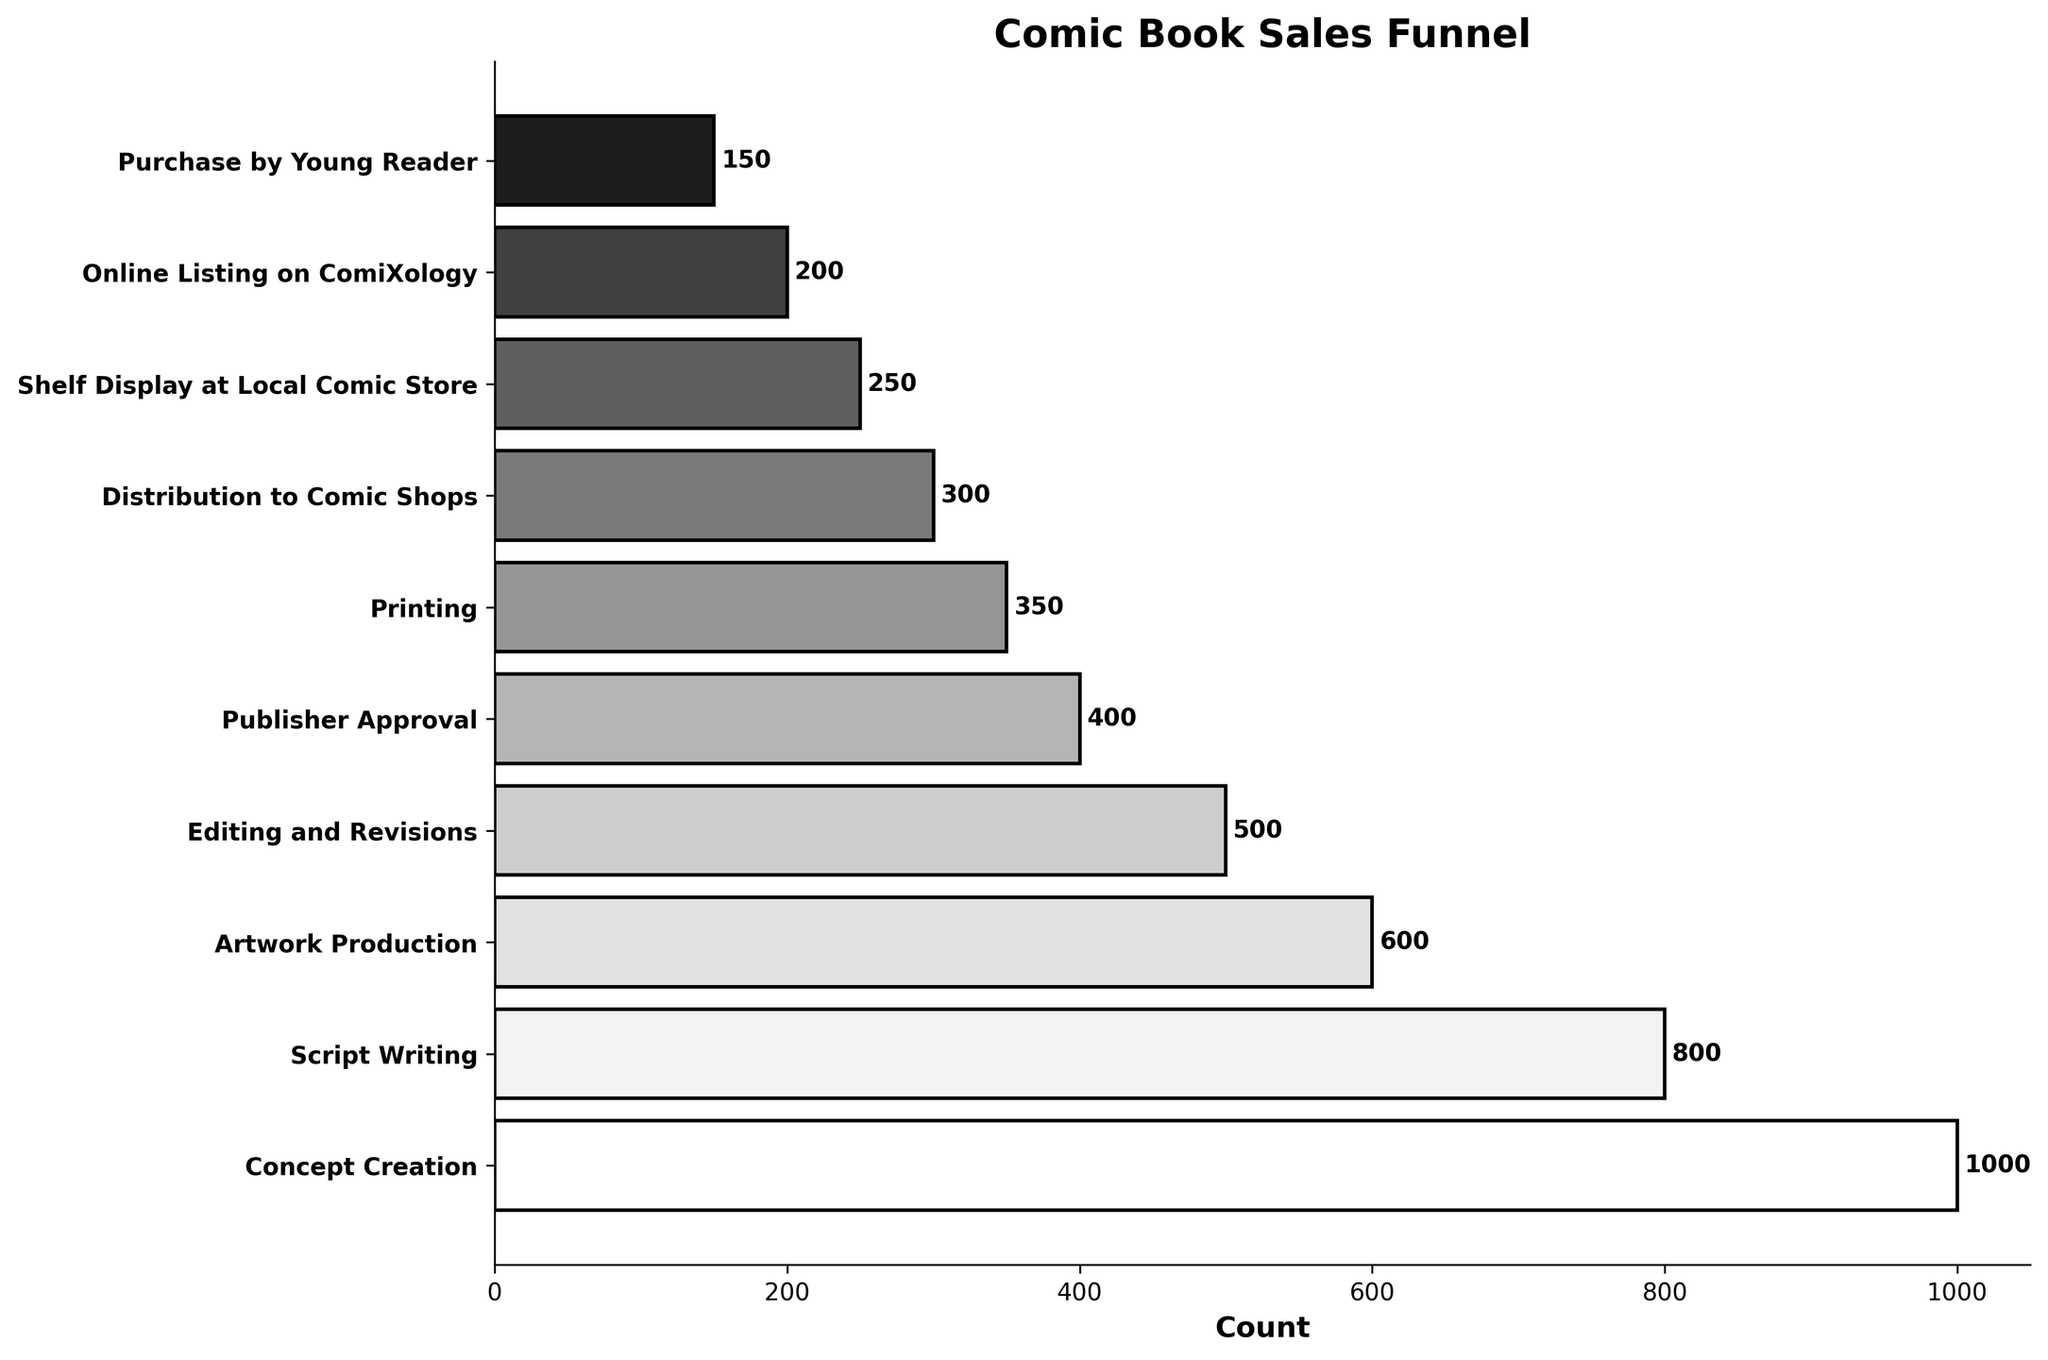What's the title of the figure? The title is displayed prominently at the top of the figure in bold font. It provides the context of the visualization.
Answer: Comic Book Sales Funnel How many stages are there in the comic book sales process? The y-axis of the funnel chart lists all the stages in the process, each represented as a horizontal bar. Counting these bars will give the number of stages.
Answer: 10 What is the count at the "Script Writing" stage? Looking at the bar labeled "Script Writing," the count label next to it is the value we are looking for.
Answer: 800 How many more comics are at the "Concept Creation" stage compared to the "Shelf Display at Local Comic Store" stage? Subtract the count at the "Shelf Display at Local Comic Store" stage from the count at the "Concept Creation" stage. 1000 - 250 = 750
Answer: 750 Which stage has the smallest count, and what is that count? Identifying the shortest bar in the funnel chart will reveal the stage with the smallest count. The count label next to this bar will provide the exact number.
Answer: Purchase by Young Reader, 150 What is the total number of comics from "Printing" to "Purchase by Young Reader"? Adding the counts for all the stages from "Printing" to "Purchase by Young Reader": 350 + 300 + 250 + 200 + 150. Sum these values to get the total. 350 + 300 + 250 + 200 + 150 = 1250
Answer: 1250 Which stage follows "Editing and Revisions" and what is its count? The stage right after "Editing and Revisions" on the y-axis is the one that follows it directly. The count next to this stage will give the required number.
Answer: Publisher Approval, 400 How many stages have counts greater than 500? Identify and count all the stages with horizontal bars extending beyond the 500 mark on the x-axis.
Answer: 3 What is the difference between the counts at "Concept Creation" and "Printing"? Subtract the count of the "Printing" stage from the "Concept Creation" stage: 1000 - 350 = 650
Answer: 650 What percentage of the initial 1000 comics make it to the "Purchase by Young Reader" stage? Divide the count at "Purchase by Young Reader" by the count at "Concept Creation" and multiply by 100 to get the percentage. (150 / 1000) * 100 = 15%
Answer: 15% 